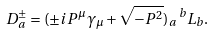Convert formula to latex. <formula><loc_0><loc_0><loc_500><loc_500>D ^ { \pm } _ { a } = ( \pm i P ^ { \mu } \gamma _ { \mu } + \sqrt { - P ^ { 2 } } ) _ { a } \, ^ { b } L _ { b } .</formula> 